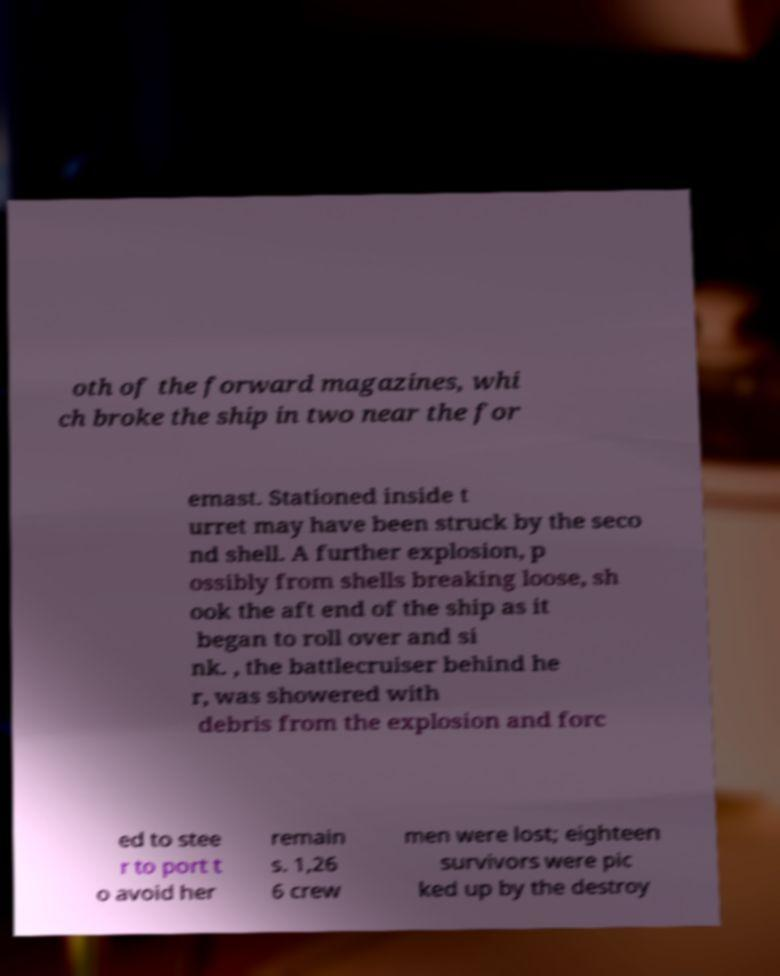There's text embedded in this image that I need extracted. Can you transcribe it verbatim? oth of the forward magazines, whi ch broke the ship in two near the for emast. Stationed inside t urret may have been struck by the seco nd shell. A further explosion, p ossibly from shells breaking loose, sh ook the aft end of the ship as it began to roll over and si nk. , the battlecruiser behind he r, was showered with debris from the explosion and forc ed to stee r to port t o avoid her remain s. 1,26 6 crew men were lost; eighteen survivors were pic ked up by the destroy 